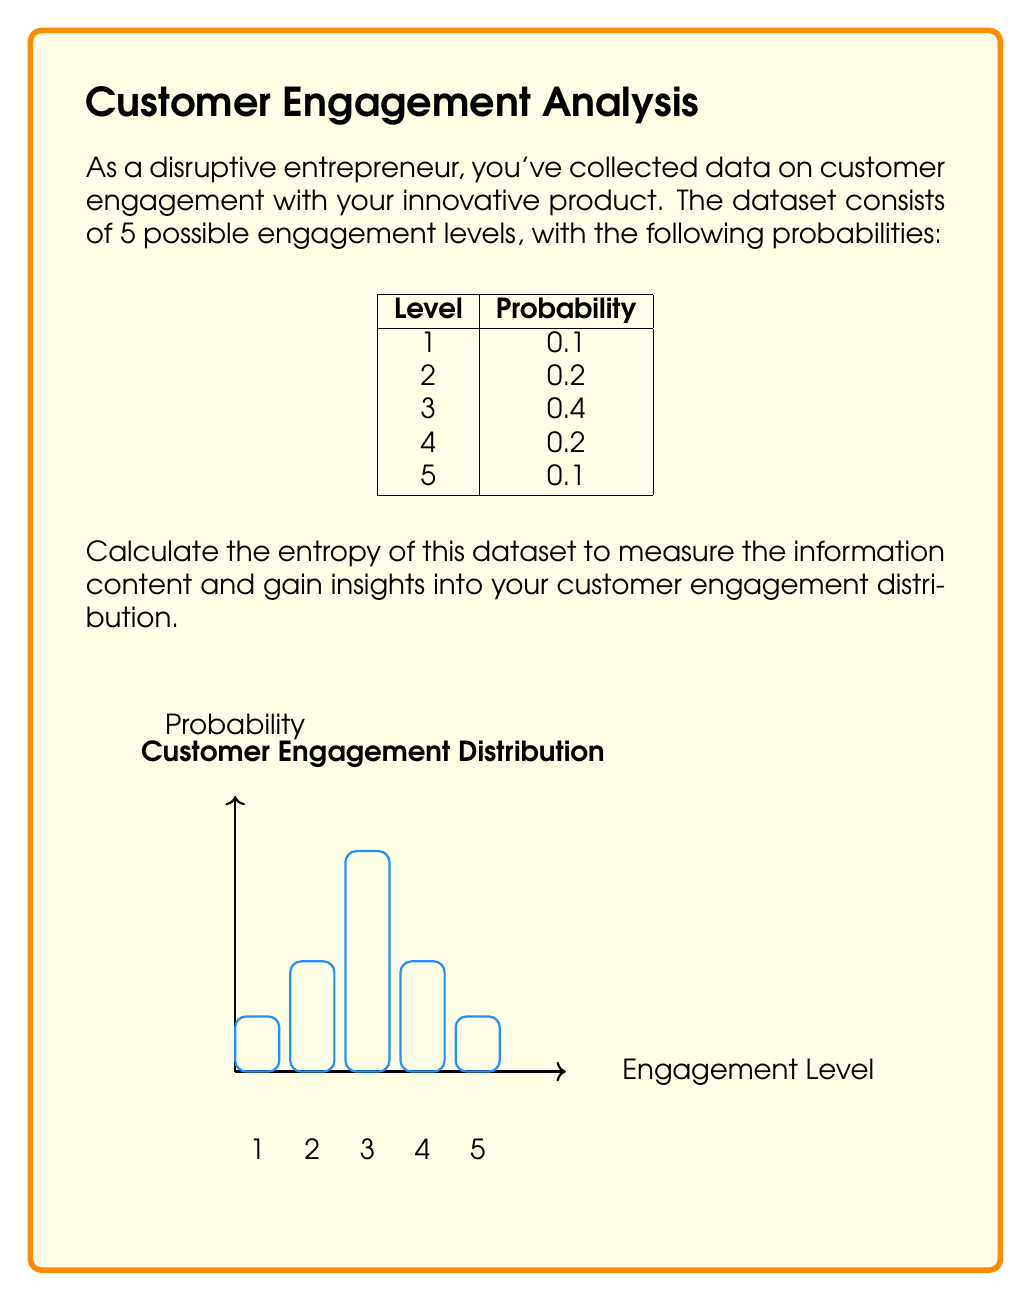Provide a solution to this math problem. To calculate the entropy of the dataset, we'll use the formula for Shannon entropy:

$$H = -\sum_{i=1}^{n} p_i \log_2(p_i)$$

Where $p_i$ is the probability of each event, and $n$ is the number of possible events.

Step 1: Calculate $p_i \log_2(p_i)$ for each engagement level:

Level 1: $-0.1 \log_2(0.1) = 0.332$
Level 2: $-0.2 \log_2(0.2) = 0.464$
Level 3: $-0.4 \log_2(0.4) = 0.528$
Level 4: $-0.2 \log_2(0.2) = 0.464$
Level 5: $-0.1 \log_2(0.1) = 0.332$

Step 2: Sum up all the values:

$$H = 0.332 + 0.464 + 0.528 + 0.464 + 0.332 = 2.12$$

The entropy of the dataset is approximately 2.12 bits.

Interpretation: This value indicates the average amount of information contained in each engagement level. A higher entropy suggests more uncertainty or diversity in the engagement levels, while a lower entropy would indicate more predictability or concentration around certain levels.
Answer: 2.12 bits 